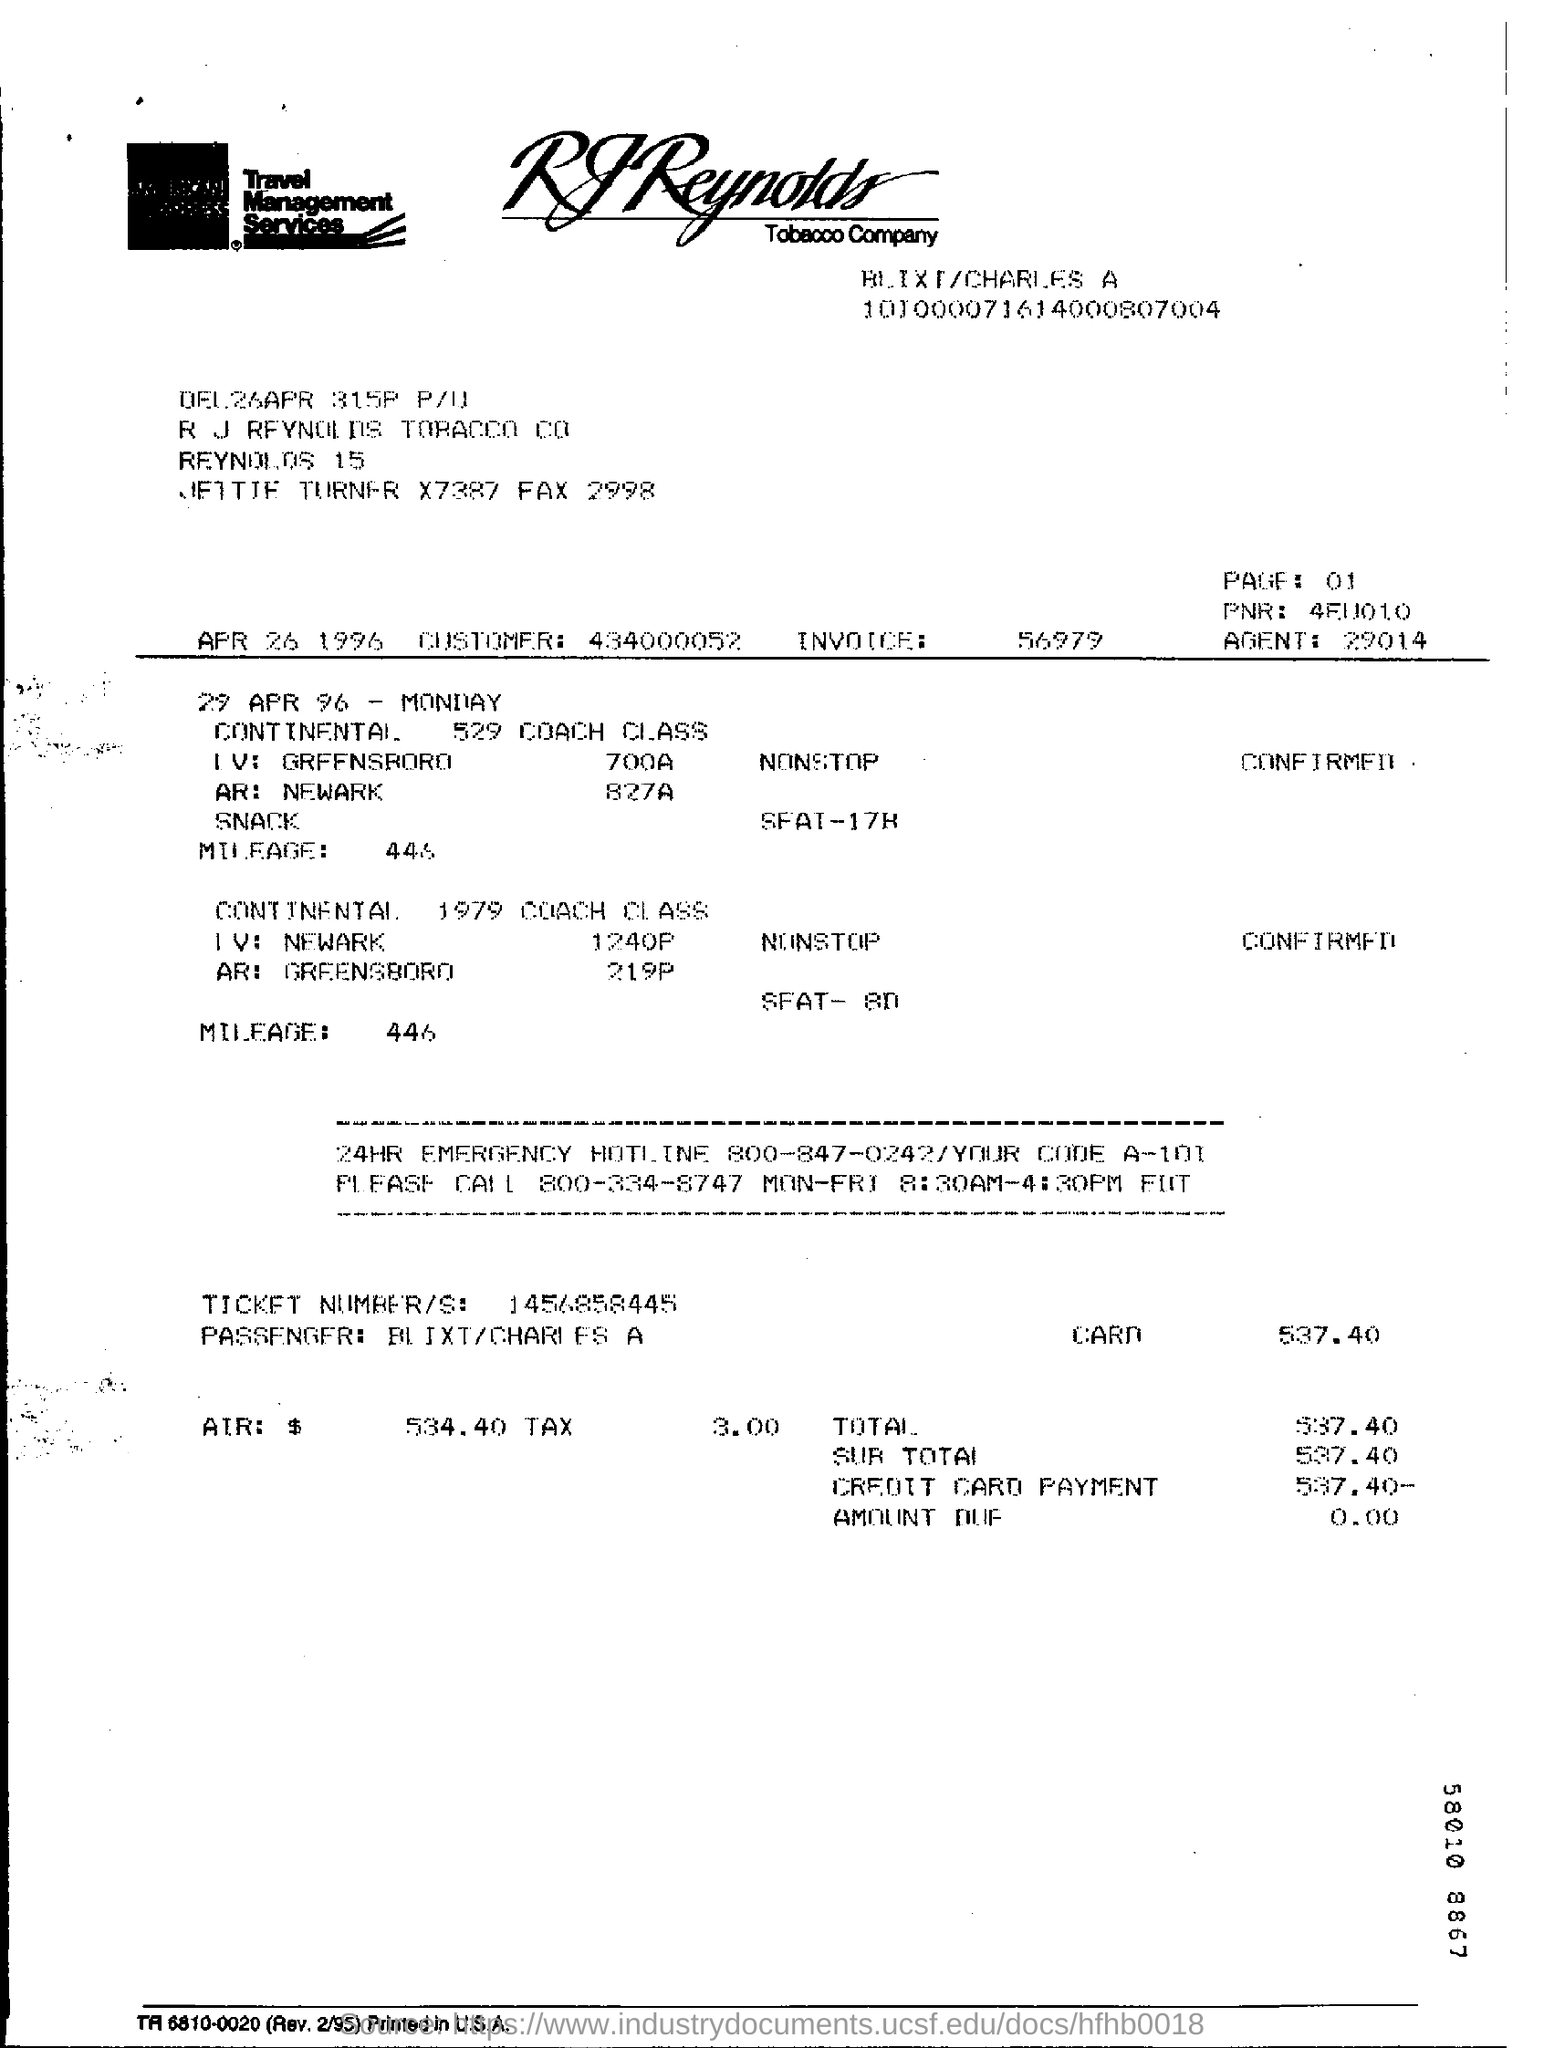What is the invoice number ?
Your response must be concise. 56979. What day of the week is 29 apr 96?
Provide a succinct answer. Monday. How much is the total ?
Your response must be concise. 537.40. 